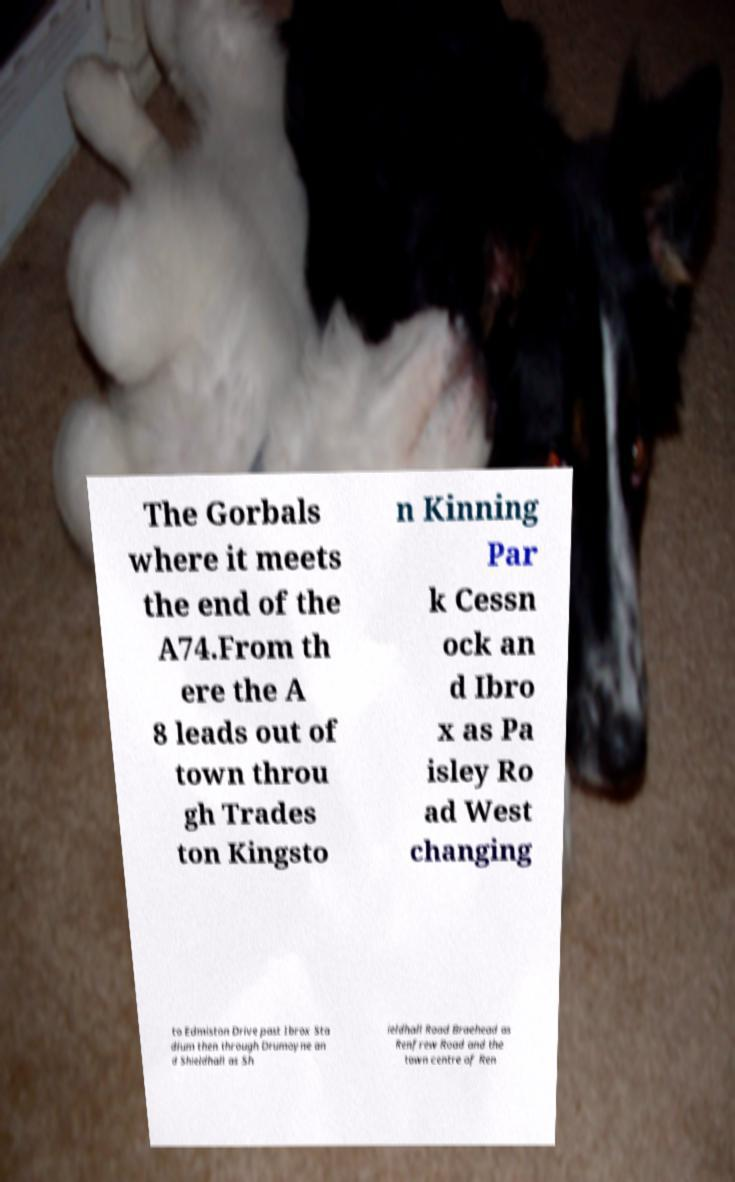There's text embedded in this image that I need extracted. Can you transcribe it verbatim? The Gorbals where it meets the end of the A74.From th ere the A 8 leads out of town throu gh Trades ton Kingsto n Kinning Par k Cessn ock an d Ibro x as Pa isley Ro ad West changing to Edmiston Drive past Ibrox Sta dium then through Drumoyne an d Shieldhall as Sh ieldhall Road Braehead as Renfrew Road and the town centre of Ren 